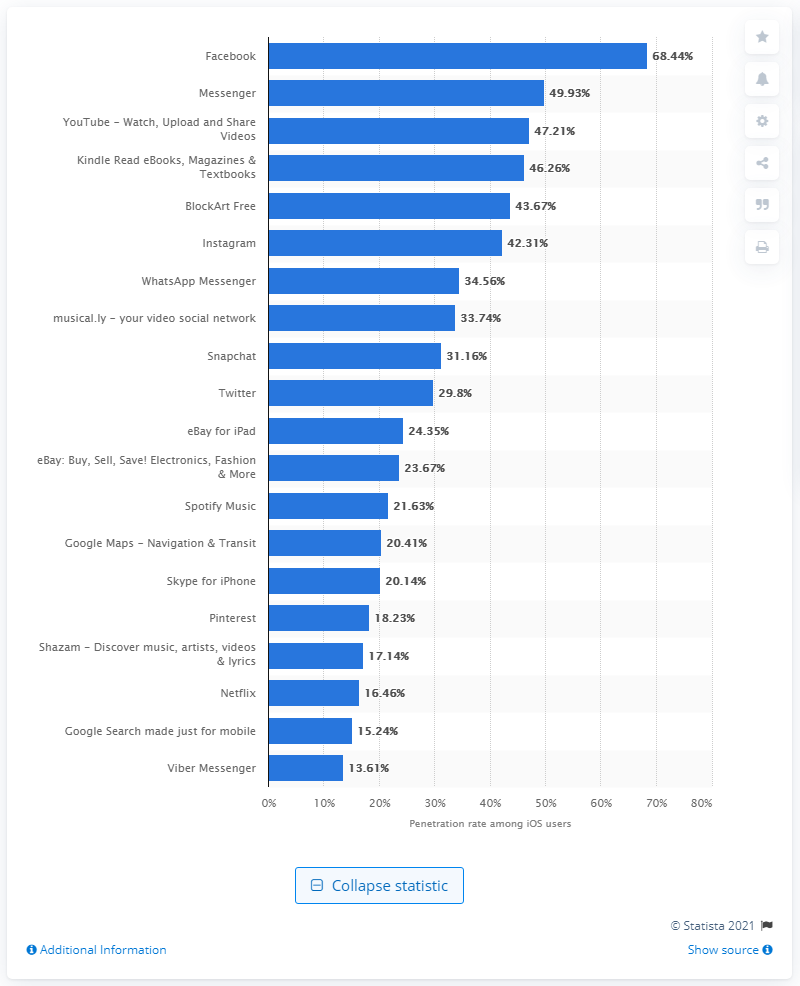List a handful of essential elements in this visual. According to data, Facebook had the highest reach among mobile iOS users in the UK with 68.44 percent. 